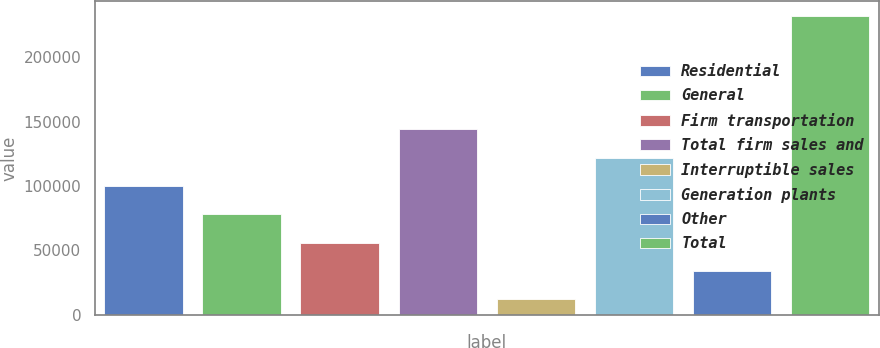<chart> <loc_0><loc_0><loc_500><loc_500><bar_chart><fcel>Residential<fcel>General<fcel>Firm transportation<fcel>Total firm sales and<fcel>Interruptible sales<fcel>Generation plants<fcel>Other<fcel>Total<nl><fcel>100112<fcel>78082.6<fcel>56053.4<fcel>144170<fcel>11995<fcel>122141<fcel>34024.2<fcel>232287<nl></chart> 